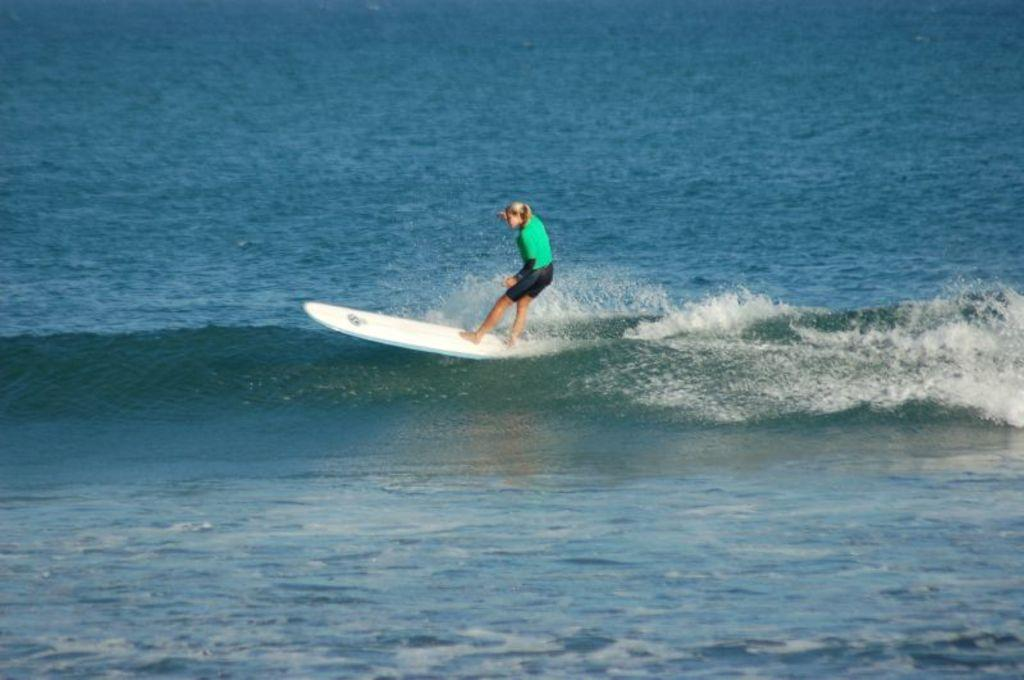What activity is the person in the image engaged in? The person in the image is surfing. What object is the person using to surf? There is a surfboard on the water in the image. What type of frame is surrounding the person surfing in the image? There is no frame surrounding the person surfing in the image. Can you see any snakes or flowers in the image? No, there are no snakes or flowers present in the image. 